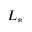<formula> <loc_0><loc_0><loc_500><loc_500>L _ { * }</formula> 